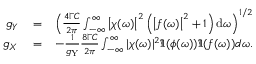Convert formula to latex. <formula><loc_0><loc_0><loc_500><loc_500>\begin{array} { r l r } { g _ { Y } } & = } & { \left ( \frac { 4 \Gamma C } { 2 \pi } \int _ { - \infty } ^ { \infty } \left | \chi ( \omega ) \right | ^ { 2 } \left ( \left | f ( \omega ) \right | ^ { 2 } + 1 \right ) d \omega \right ) ^ { 1 / 2 } } \\ { g _ { X } } & = } & { - \frac { 1 } { g _ { Y } } \frac { 8 \Gamma C } { 2 \pi } \int _ { - \infty } ^ { \infty } | \chi ( \omega ) | ^ { 2 } \Im { ( \phi ( \omega ) ) \Im { ( f ( \omega ) ) } } d \omega . } \end{array}</formula> 